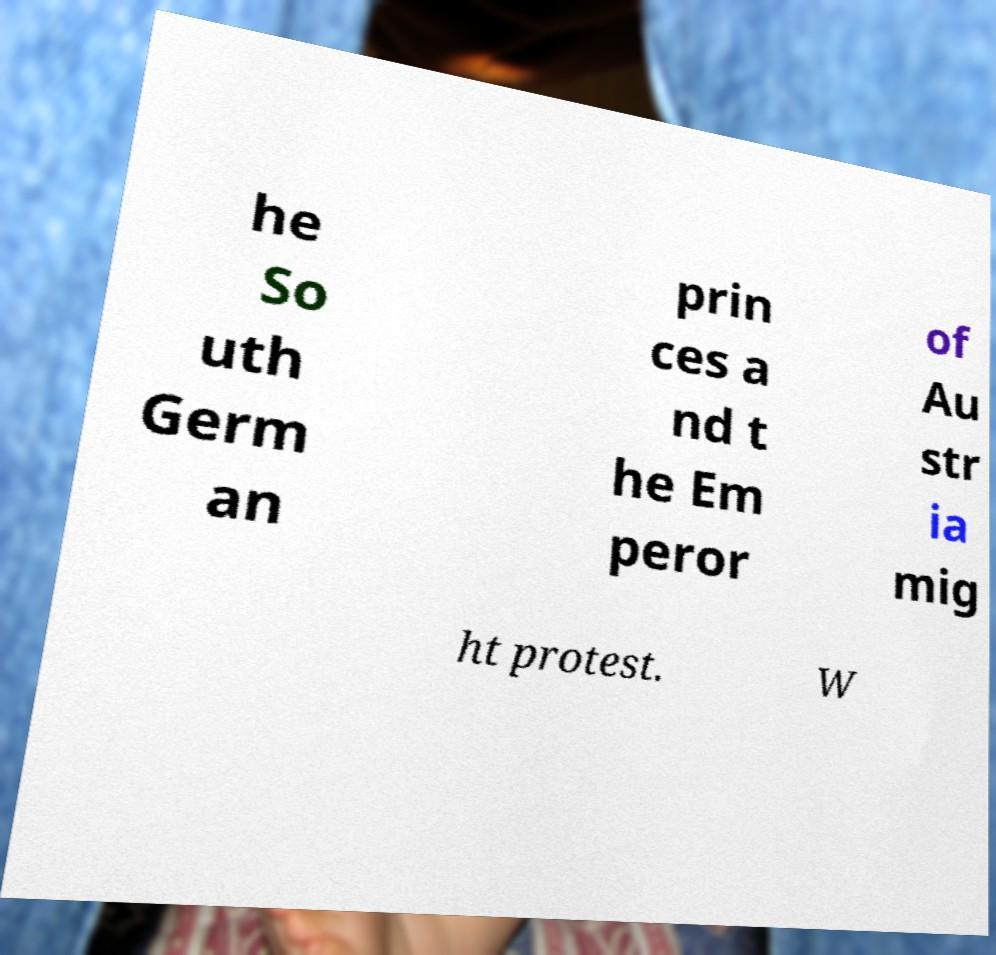For documentation purposes, I need the text within this image transcribed. Could you provide that? he So uth Germ an prin ces a nd t he Em peror of Au str ia mig ht protest. W 